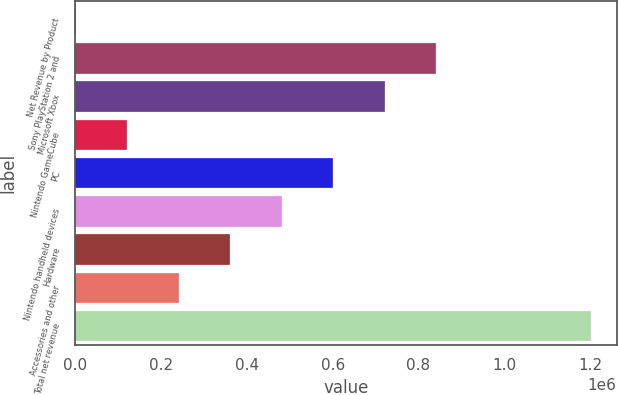Convert chart to OTSL. <chart><loc_0><loc_0><loc_500><loc_500><bar_chart><fcel>Net Revenue by Product<fcel>Sony PlayStation 2 and<fcel>Microsoft Xbox<fcel>Nintendo GameCube<fcel>PC<fcel>Nintendo handheld devices<fcel>Hardware<fcel>Accessories and other<fcel>Total net revenue<nl><fcel>2005<fcel>841456<fcel>721534<fcel>121926<fcel>601612<fcel>481691<fcel>361770<fcel>241848<fcel>1.20122e+06<nl></chart> 